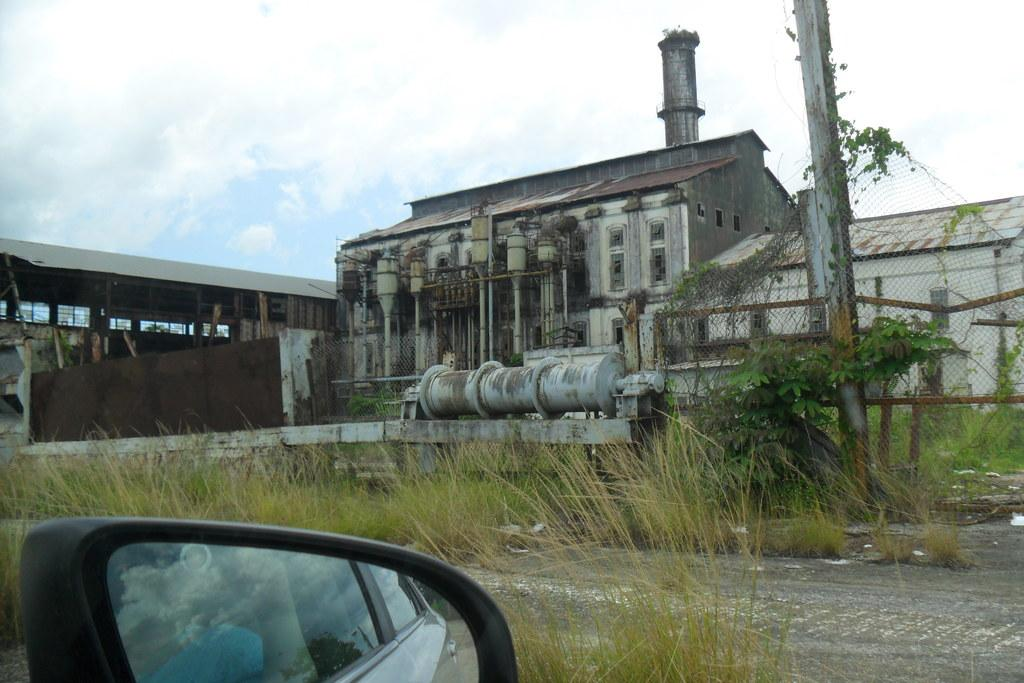What is located on the left-hand side bottom of the image? There is a mirror of a vehicle in the left-hand side bottom of the image. What can be seen in the middle of the image? There are machines in the middle of the image, resembling a factory. What is visible at the top of the image? The sky is visible at the top of the image, and it appears to be cloudy. What year is listed on the mirror of the vehicle in the image? There is no year listed on the mirror of the vehicle in the image. What type of drain is visible in the image? There is no drain present in the image. 